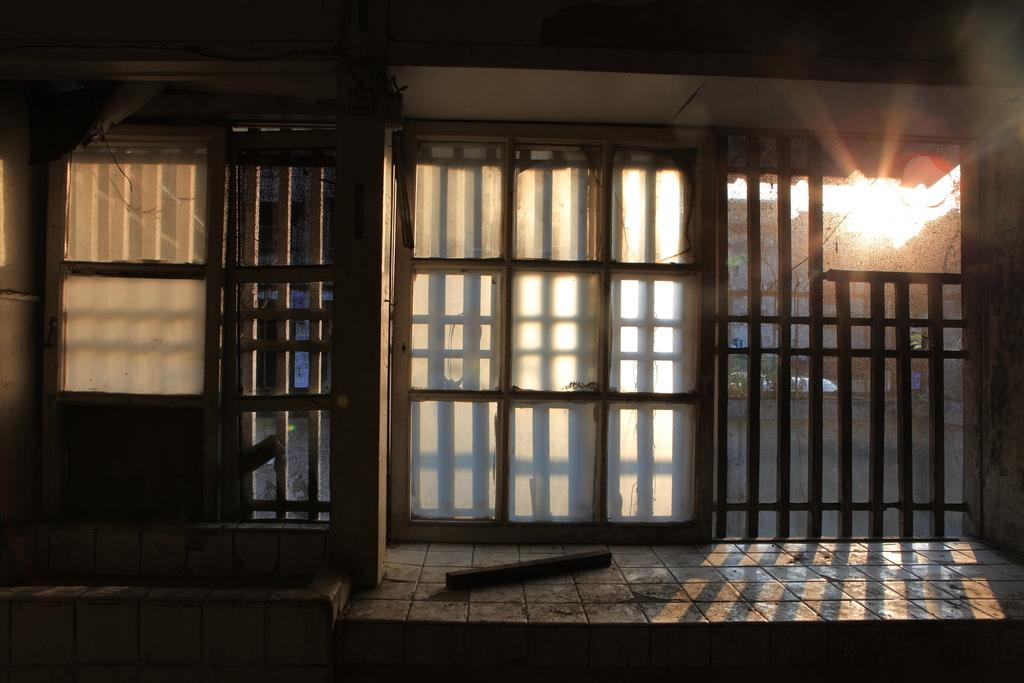What is located in the center of the image? There are windows in the center of the image. What can be seen through the windows? Trees are visible behind the windows. Can you see the seashore through the windows in the image? No, the provided facts do not mention a seashore being visible through the windows. The image only shows trees visible behind the windows. 